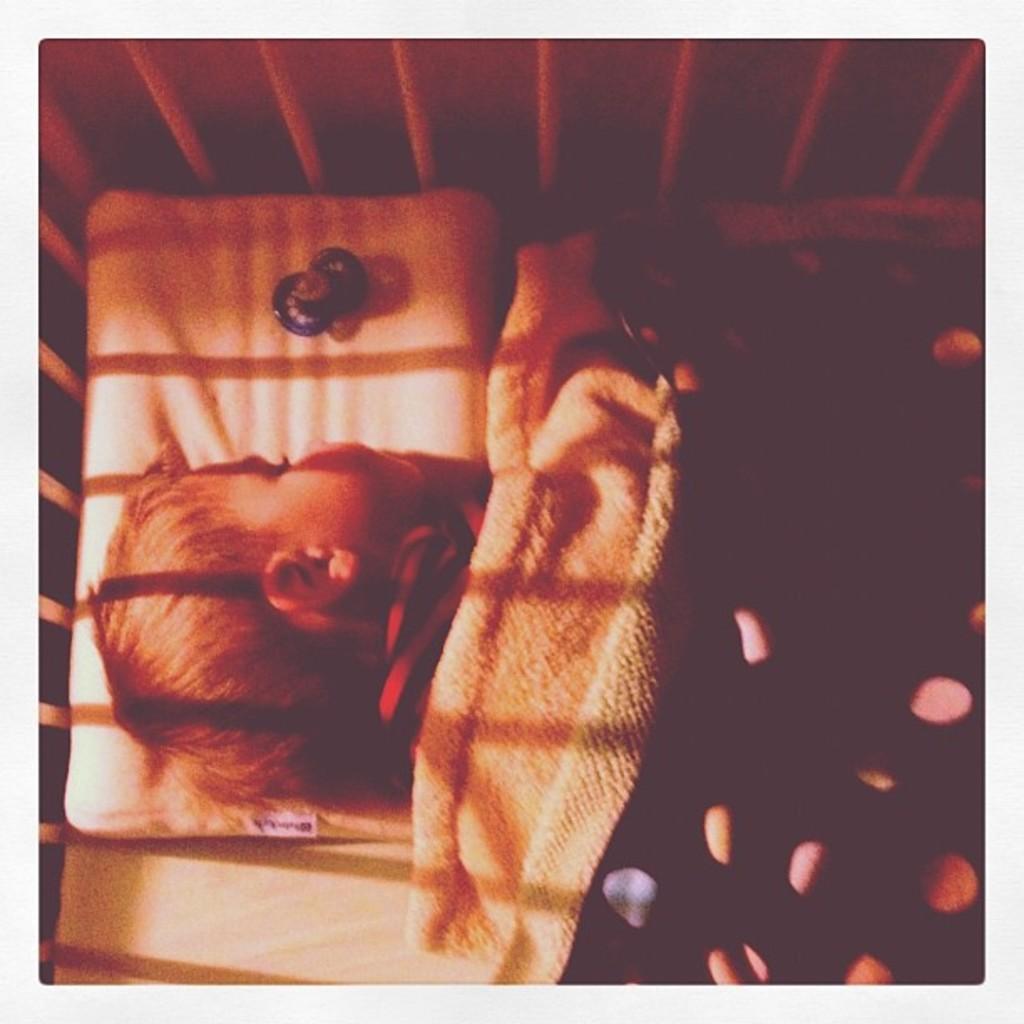Describe this image in one or two sentences. In this image in the center there is a person sleeping. On the top of the person there is a blanket and on the top there is a grill which is white in colour. 